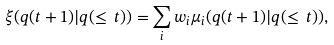Convert formula to latex. <formula><loc_0><loc_0><loc_500><loc_500>\xi ( q ( t + 1 ) | q ( \leq \, t ) ) = \sum _ { i } w _ { i } \mu _ { i } ( q ( t + 1 ) | q ( \leq \, t ) ) ,</formula> 